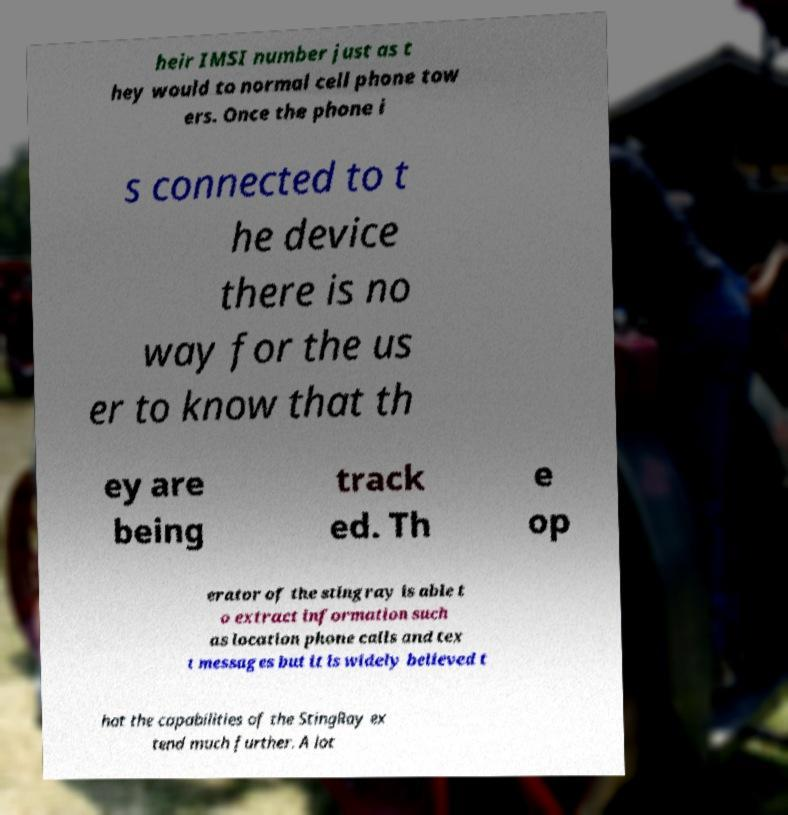Please identify and transcribe the text found in this image. heir IMSI number just as t hey would to normal cell phone tow ers. Once the phone i s connected to t he device there is no way for the us er to know that th ey are being track ed. Th e op erator of the stingray is able t o extract information such as location phone calls and tex t messages but it is widely believed t hat the capabilities of the StingRay ex tend much further. A lot 